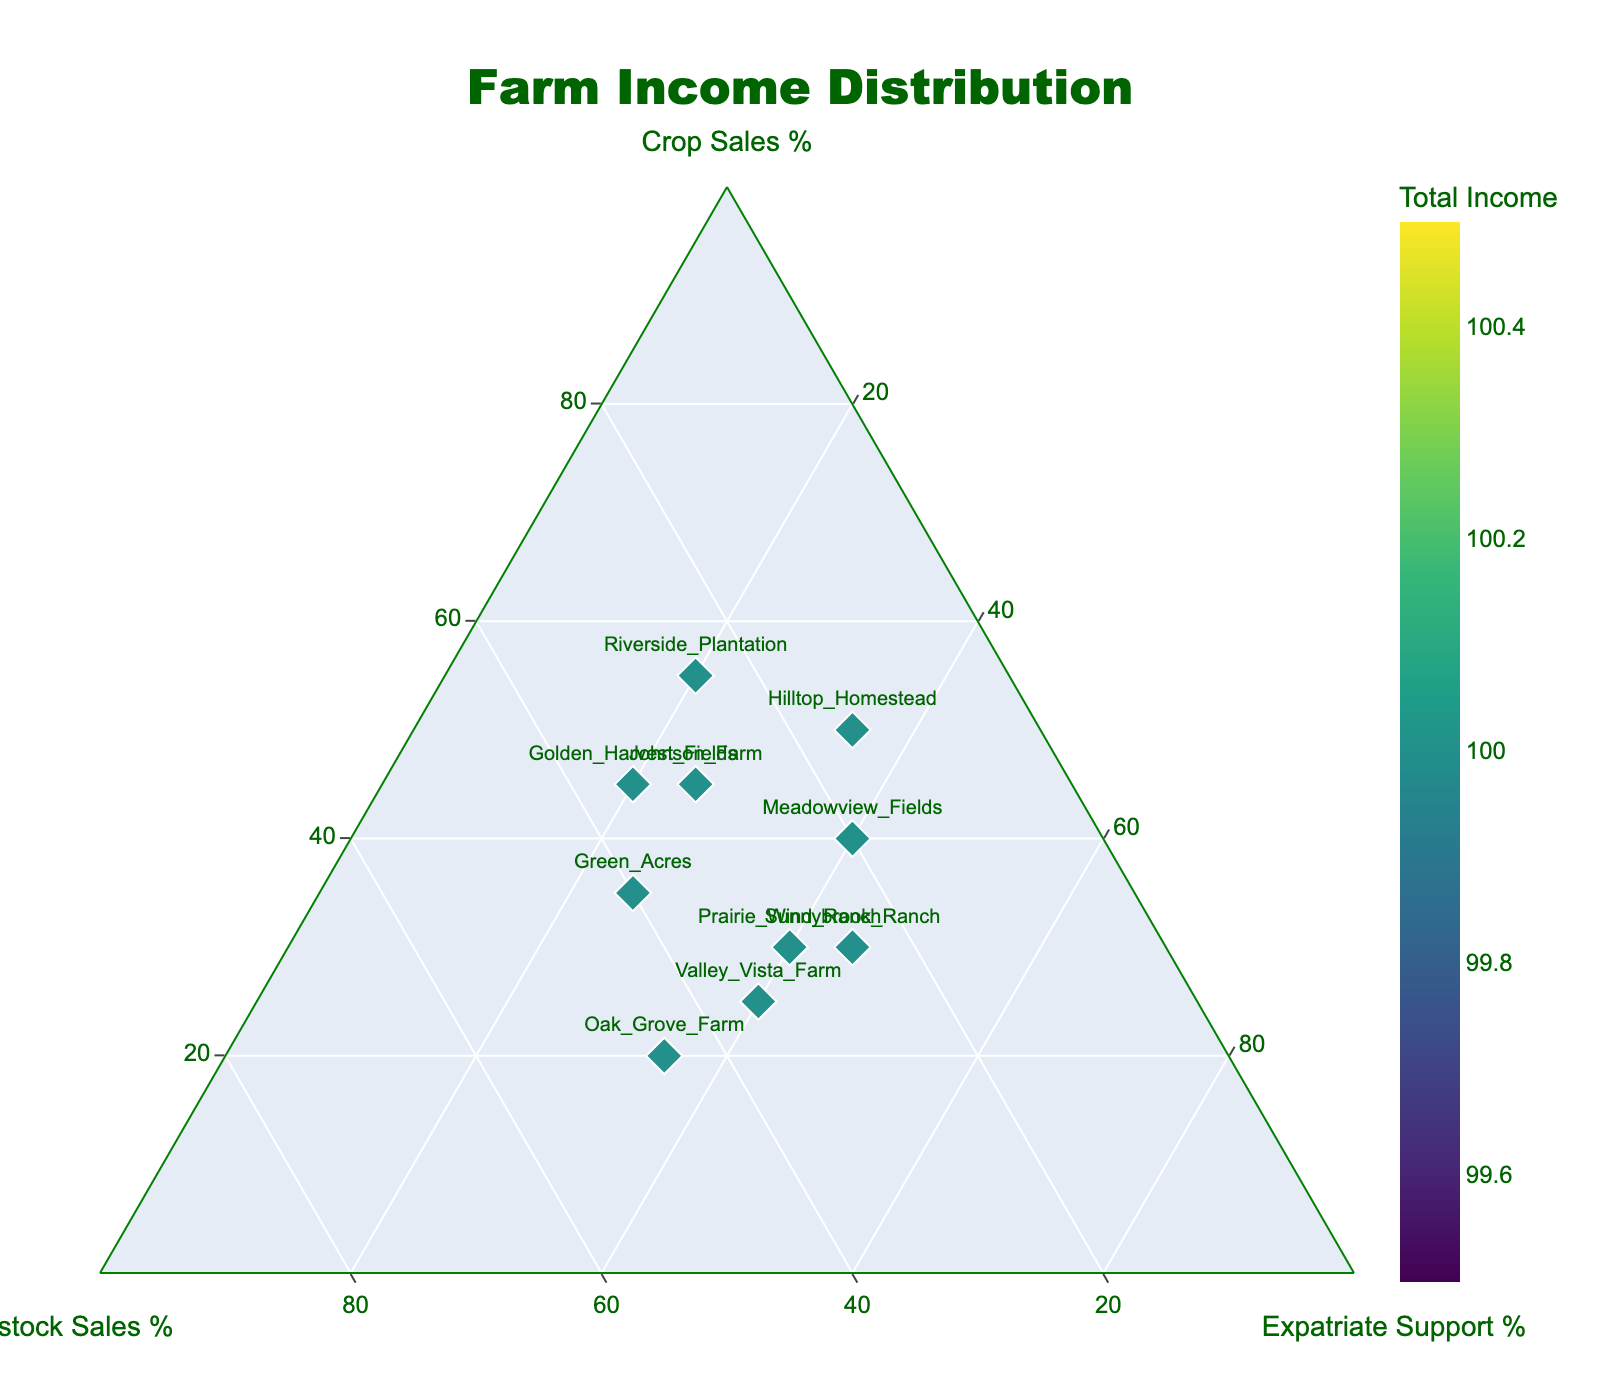What is the title of the figure? The title is usually displayed prominently at the top of the figure. In this case, it is the large text centered and placed at the top.
Answer: Farm Income Distribution How many farms have a higher percentage of crop sales than livestock sales? To answer this, look at the data points on the plot and compare the values on the crop sales axis to the values on the livestock sales axis for each of the ten farms.
Answer: 6 In which farm does financial support from an expatriate family member contribute the most to the total income? Look for the farm with the highest value on the Expatriate Support axis of the ternary plot.
Answer: Sunnybrook_Ranch What is the average percentage of livestock sales for Oak_Grove_Farm and Green_Acres? Find the livestock sales percentages for both Oak_Grove_Farm (45%) and Green_Acres (40%), then calculate the average: (45% + 40%) / 2 = 42.5%
Answer: 42.5% Which farm has the least contribution from crop sales in its income distribution? Locate the data point with the smallest value on the Crop Sales axis.
Answer: Oak_Grove_Farm Is there any farm where crop sales make up exactly half of the total income? Check if any data points have a value of 50% on the Crop Sales axis.
Answer: No For Hilltop_Homestead, compare the contribution from crop sales to the contribution from expatriate support. Which is higher? Look at the values for Hilltop_Homestead on the Crop Sales axis (50%) and Expatriate Support axis (35%), and compare them.
Answer: Crop sales Calculate the sum of the percentages for Meadowview_Fields in all three categories: crop sales, livestock sales, and financial support from expatriate family. Crop Sales (40%) + Livestock Sales (20%) + Expatriate Support (40%) = 100%.
Answer: 100% Which farm has the most balanced contribution across all three income sources? Identify the farm whose data point is closest to the center of the ternary plot, indicating a relatively even distribution among the three income sources.
Answer: Prairie_Wind_Ranch What is the difference in crop sales percentage between Riverside_Plantation and Golden_Harvest_Fields? Subtract the Crop Sales percentage of Golden_Harvest_Fields (45%) from that of Riverside_Plantation (55%): 55% - 45% = 10%.
Answer: 10% 